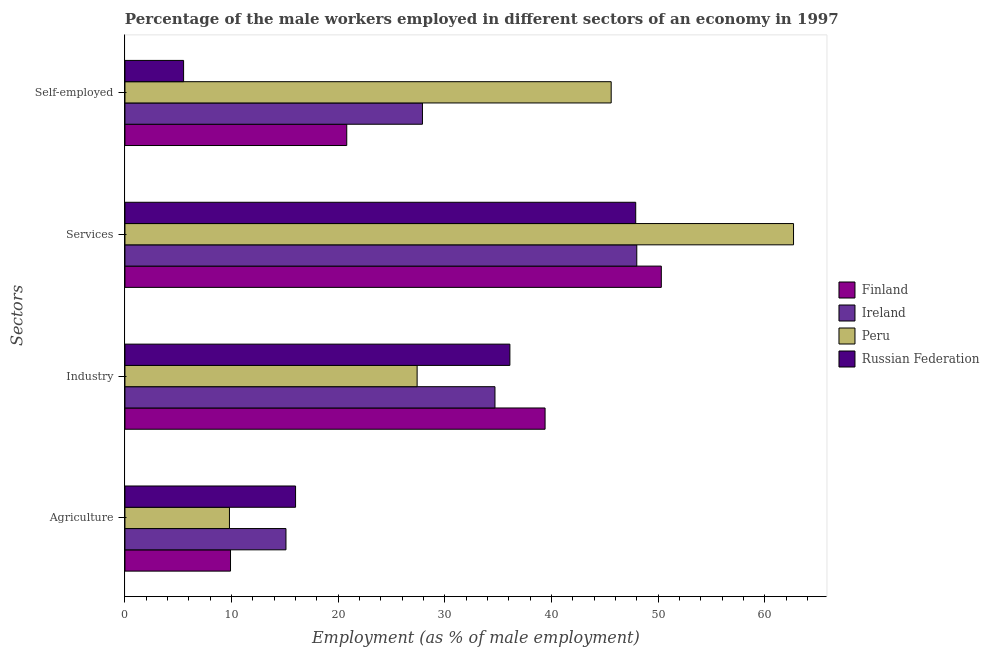How many different coloured bars are there?
Offer a terse response. 4. How many bars are there on the 4th tick from the top?
Make the answer very short. 4. What is the label of the 4th group of bars from the top?
Provide a succinct answer. Agriculture. What is the percentage of male workers in agriculture in Finland?
Offer a terse response. 9.9. Across all countries, what is the maximum percentage of male workers in industry?
Your response must be concise. 39.4. In which country was the percentage of male workers in agriculture maximum?
Offer a very short reply. Russian Federation. In which country was the percentage of male workers in agriculture minimum?
Provide a short and direct response. Peru. What is the total percentage of male workers in agriculture in the graph?
Give a very brief answer. 50.8. What is the difference between the percentage of self employed male workers in Russian Federation and that in Peru?
Keep it short and to the point. -40.1. What is the difference between the percentage of self employed male workers in Russian Federation and the percentage of male workers in services in Peru?
Give a very brief answer. -57.2. What is the average percentage of male workers in industry per country?
Your answer should be very brief. 34.4. What is the difference between the percentage of male workers in agriculture and percentage of male workers in services in Peru?
Make the answer very short. -52.9. What is the ratio of the percentage of male workers in industry in Russian Federation to that in Peru?
Your answer should be very brief. 1.32. Is the percentage of male workers in industry in Russian Federation less than that in Finland?
Your answer should be very brief. Yes. Is the difference between the percentage of male workers in industry in Ireland and Russian Federation greater than the difference between the percentage of male workers in services in Ireland and Russian Federation?
Provide a short and direct response. No. What is the difference between the highest and the second highest percentage of self employed male workers?
Your answer should be compact. 17.7. What is the difference between the highest and the lowest percentage of male workers in agriculture?
Give a very brief answer. 6.2. Is the sum of the percentage of male workers in services in Finland and Peru greater than the maximum percentage of self employed male workers across all countries?
Offer a terse response. Yes. What does the 3rd bar from the top in Services represents?
Give a very brief answer. Ireland. How many bars are there?
Provide a succinct answer. 16. Are all the bars in the graph horizontal?
Provide a short and direct response. Yes. Does the graph contain any zero values?
Make the answer very short. No. What is the title of the graph?
Ensure brevity in your answer.  Percentage of the male workers employed in different sectors of an economy in 1997. What is the label or title of the X-axis?
Give a very brief answer. Employment (as % of male employment). What is the label or title of the Y-axis?
Give a very brief answer. Sectors. What is the Employment (as % of male employment) in Finland in Agriculture?
Ensure brevity in your answer.  9.9. What is the Employment (as % of male employment) of Ireland in Agriculture?
Offer a terse response. 15.1. What is the Employment (as % of male employment) of Peru in Agriculture?
Offer a terse response. 9.8. What is the Employment (as % of male employment) of Russian Federation in Agriculture?
Give a very brief answer. 16. What is the Employment (as % of male employment) of Finland in Industry?
Ensure brevity in your answer.  39.4. What is the Employment (as % of male employment) of Ireland in Industry?
Keep it short and to the point. 34.7. What is the Employment (as % of male employment) of Peru in Industry?
Offer a very short reply. 27.4. What is the Employment (as % of male employment) of Russian Federation in Industry?
Ensure brevity in your answer.  36.1. What is the Employment (as % of male employment) of Finland in Services?
Make the answer very short. 50.3. What is the Employment (as % of male employment) in Ireland in Services?
Offer a terse response. 48. What is the Employment (as % of male employment) of Peru in Services?
Your answer should be very brief. 62.7. What is the Employment (as % of male employment) of Russian Federation in Services?
Offer a very short reply. 47.9. What is the Employment (as % of male employment) of Finland in Self-employed?
Ensure brevity in your answer.  20.8. What is the Employment (as % of male employment) in Ireland in Self-employed?
Your answer should be compact. 27.9. What is the Employment (as % of male employment) in Peru in Self-employed?
Your response must be concise. 45.6. What is the Employment (as % of male employment) in Russian Federation in Self-employed?
Offer a very short reply. 5.5. Across all Sectors, what is the maximum Employment (as % of male employment) in Finland?
Provide a short and direct response. 50.3. Across all Sectors, what is the maximum Employment (as % of male employment) of Ireland?
Offer a very short reply. 48. Across all Sectors, what is the maximum Employment (as % of male employment) of Peru?
Offer a very short reply. 62.7. Across all Sectors, what is the maximum Employment (as % of male employment) of Russian Federation?
Give a very brief answer. 47.9. Across all Sectors, what is the minimum Employment (as % of male employment) in Finland?
Offer a very short reply. 9.9. Across all Sectors, what is the minimum Employment (as % of male employment) of Ireland?
Offer a very short reply. 15.1. Across all Sectors, what is the minimum Employment (as % of male employment) in Peru?
Keep it short and to the point. 9.8. Across all Sectors, what is the minimum Employment (as % of male employment) in Russian Federation?
Your answer should be compact. 5.5. What is the total Employment (as % of male employment) of Finland in the graph?
Offer a terse response. 120.4. What is the total Employment (as % of male employment) in Ireland in the graph?
Offer a very short reply. 125.7. What is the total Employment (as % of male employment) of Peru in the graph?
Offer a very short reply. 145.5. What is the total Employment (as % of male employment) of Russian Federation in the graph?
Ensure brevity in your answer.  105.5. What is the difference between the Employment (as % of male employment) of Finland in Agriculture and that in Industry?
Keep it short and to the point. -29.5. What is the difference between the Employment (as % of male employment) in Ireland in Agriculture and that in Industry?
Give a very brief answer. -19.6. What is the difference between the Employment (as % of male employment) of Peru in Agriculture and that in Industry?
Ensure brevity in your answer.  -17.6. What is the difference between the Employment (as % of male employment) in Russian Federation in Agriculture and that in Industry?
Make the answer very short. -20.1. What is the difference between the Employment (as % of male employment) of Finland in Agriculture and that in Services?
Provide a short and direct response. -40.4. What is the difference between the Employment (as % of male employment) in Ireland in Agriculture and that in Services?
Keep it short and to the point. -32.9. What is the difference between the Employment (as % of male employment) in Peru in Agriculture and that in Services?
Keep it short and to the point. -52.9. What is the difference between the Employment (as % of male employment) in Russian Federation in Agriculture and that in Services?
Give a very brief answer. -31.9. What is the difference between the Employment (as % of male employment) in Ireland in Agriculture and that in Self-employed?
Offer a terse response. -12.8. What is the difference between the Employment (as % of male employment) of Peru in Agriculture and that in Self-employed?
Provide a succinct answer. -35.8. What is the difference between the Employment (as % of male employment) of Russian Federation in Agriculture and that in Self-employed?
Keep it short and to the point. 10.5. What is the difference between the Employment (as % of male employment) in Finland in Industry and that in Services?
Offer a terse response. -10.9. What is the difference between the Employment (as % of male employment) in Ireland in Industry and that in Services?
Offer a very short reply. -13.3. What is the difference between the Employment (as % of male employment) of Peru in Industry and that in Services?
Your answer should be compact. -35.3. What is the difference between the Employment (as % of male employment) in Ireland in Industry and that in Self-employed?
Make the answer very short. 6.8. What is the difference between the Employment (as % of male employment) of Peru in Industry and that in Self-employed?
Provide a succinct answer. -18.2. What is the difference between the Employment (as % of male employment) of Russian Federation in Industry and that in Self-employed?
Your response must be concise. 30.6. What is the difference between the Employment (as % of male employment) of Finland in Services and that in Self-employed?
Provide a short and direct response. 29.5. What is the difference between the Employment (as % of male employment) in Ireland in Services and that in Self-employed?
Keep it short and to the point. 20.1. What is the difference between the Employment (as % of male employment) of Russian Federation in Services and that in Self-employed?
Your answer should be very brief. 42.4. What is the difference between the Employment (as % of male employment) in Finland in Agriculture and the Employment (as % of male employment) in Ireland in Industry?
Offer a terse response. -24.8. What is the difference between the Employment (as % of male employment) of Finland in Agriculture and the Employment (as % of male employment) of Peru in Industry?
Give a very brief answer. -17.5. What is the difference between the Employment (as % of male employment) of Finland in Agriculture and the Employment (as % of male employment) of Russian Federation in Industry?
Offer a terse response. -26.2. What is the difference between the Employment (as % of male employment) of Peru in Agriculture and the Employment (as % of male employment) of Russian Federation in Industry?
Keep it short and to the point. -26.3. What is the difference between the Employment (as % of male employment) in Finland in Agriculture and the Employment (as % of male employment) in Ireland in Services?
Ensure brevity in your answer.  -38.1. What is the difference between the Employment (as % of male employment) of Finland in Agriculture and the Employment (as % of male employment) of Peru in Services?
Provide a short and direct response. -52.8. What is the difference between the Employment (as % of male employment) in Finland in Agriculture and the Employment (as % of male employment) in Russian Federation in Services?
Offer a terse response. -38. What is the difference between the Employment (as % of male employment) in Ireland in Agriculture and the Employment (as % of male employment) in Peru in Services?
Ensure brevity in your answer.  -47.6. What is the difference between the Employment (as % of male employment) of Ireland in Agriculture and the Employment (as % of male employment) of Russian Federation in Services?
Provide a succinct answer. -32.8. What is the difference between the Employment (as % of male employment) of Peru in Agriculture and the Employment (as % of male employment) of Russian Federation in Services?
Give a very brief answer. -38.1. What is the difference between the Employment (as % of male employment) in Finland in Agriculture and the Employment (as % of male employment) in Ireland in Self-employed?
Your answer should be compact. -18. What is the difference between the Employment (as % of male employment) of Finland in Agriculture and the Employment (as % of male employment) of Peru in Self-employed?
Make the answer very short. -35.7. What is the difference between the Employment (as % of male employment) in Finland in Agriculture and the Employment (as % of male employment) in Russian Federation in Self-employed?
Keep it short and to the point. 4.4. What is the difference between the Employment (as % of male employment) of Ireland in Agriculture and the Employment (as % of male employment) of Peru in Self-employed?
Keep it short and to the point. -30.5. What is the difference between the Employment (as % of male employment) of Finland in Industry and the Employment (as % of male employment) of Ireland in Services?
Your response must be concise. -8.6. What is the difference between the Employment (as % of male employment) of Finland in Industry and the Employment (as % of male employment) of Peru in Services?
Your answer should be very brief. -23.3. What is the difference between the Employment (as % of male employment) in Finland in Industry and the Employment (as % of male employment) in Russian Federation in Services?
Your answer should be compact. -8.5. What is the difference between the Employment (as % of male employment) of Ireland in Industry and the Employment (as % of male employment) of Peru in Services?
Offer a very short reply. -28. What is the difference between the Employment (as % of male employment) in Ireland in Industry and the Employment (as % of male employment) in Russian Federation in Services?
Offer a terse response. -13.2. What is the difference between the Employment (as % of male employment) in Peru in Industry and the Employment (as % of male employment) in Russian Federation in Services?
Give a very brief answer. -20.5. What is the difference between the Employment (as % of male employment) in Finland in Industry and the Employment (as % of male employment) in Russian Federation in Self-employed?
Provide a short and direct response. 33.9. What is the difference between the Employment (as % of male employment) in Ireland in Industry and the Employment (as % of male employment) in Peru in Self-employed?
Give a very brief answer. -10.9. What is the difference between the Employment (as % of male employment) in Ireland in Industry and the Employment (as % of male employment) in Russian Federation in Self-employed?
Provide a short and direct response. 29.2. What is the difference between the Employment (as % of male employment) of Peru in Industry and the Employment (as % of male employment) of Russian Federation in Self-employed?
Your response must be concise. 21.9. What is the difference between the Employment (as % of male employment) of Finland in Services and the Employment (as % of male employment) of Ireland in Self-employed?
Your response must be concise. 22.4. What is the difference between the Employment (as % of male employment) in Finland in Services and the Employment (as % of male employment) in Peru in Self-employed?
Make the answer very short. 4.7. What is the difference between the Employment (as % of male employment) of Finland in Services and the Employment (as % of male employment) of Russian Federation in Self-employed?
Your answer should be very brief. 44.8. What is the difference between the Employment (as % of male employment) of Ireland in Services and the Employment (as % of male employment) of Russian Federation in Self-employed?
Offer a very short reply. 42.5. What is the difference between the Employment (as % of male employment) of Peru in Services and the Employment (as % of male employment) of Russian Federation in Self-employed?
Make the answer very short. 57.2. What is the average Employment (as % of male employment) in Finland per Sectors?
Offer a terse response. 30.1. What is the average Employment (as % of male employment) of Ireland per Sectors?
Make the answer very short. 31.43. What is the average Employment (as % of male employment) of Peru per Sectors?
Your answer should be compact. 36.38. What is the average Employment (as % of male employment) of Russian Federation per Sectors?
Provide a short and direct response. 26.38. What is the difference between the Employment (as % of male employment) in Finland and Employment (as % of male employment) in Ireland in Agriculture?
Make the answer very short. -5.2. What is the difference between the Employment (as % of male employment) of Finland and Employment (as % of male employment) of Peru in Agriculture?
Your answer should be compact. 0.1. What is the difference between the Employment (as % of male employment) in Ireland and Employment (as % of male employment) in Peru in Agriculture?
Make the answer very short. 5.3. What is the difference between the Employment (as % of male employment) in Ireland and Employment (as % of male employment) in Russian Federation in Agriculture?
Your answer should be compact. -0.9. What is the difference between the Employment (as % of male employment) of Finland and Employment (as % of male employment) of Ireland in Industry?
Give a very brief answer. 4.7. What is the difference between the Employment (as % of male employment) in Finland and Employment (as % of male employment) in Russian Federation in Industry?
Your answer should be compact. 3.3. What is the difference between the Employment (as % of male employment) of Ireland and Employment (as % of male employment) of Russian Federation in Industry?
Keep it short and to the point. -1.4. What is the difference between the Employment (as % of male employment) of Peru and Employment (as % of male employment) of Russian Federation in Industry?
Your answer should be compact. -8.7. What is the difference between the Employment (as % of male employment) of Finland and Employment (as % of male employment) of Ireland in Services?
Your answer should be very brief. 2.3. What is the difference between the Employment (as % of male employment) in Finland and Employment (as % of male employment) in Peru in Services?
Ensure brevity in your answer.  -12.4. What is the difference between the Employment (as % of male employment) in Ireland and Employment (as % of male employment) in Peru in Services?
Offer a terse response. -14.7. What is the difference between the Employment (as % of male employment) in Ireland and Employment (as % of male employment) in Russian Federation in Services?
Your answer should be very brief. 0.1. What is the difference between the Employment (as % of male employment) in Peru and Employment (as % of male employment) in Russian Federation in Services?
Keep it short and to the point. 14.8. What is the difference between the Employment (as % of male employment) in Finland and Employment (as % of male employment) in Ireland in Self-employed?
Ensure brevity in your answer.  -7.1. What is the difference between the Employment (as % of male employment) of Finland and Employment (as % of male employment) of Peru in Self-employed?
Make the answer very short. -24.8. What is the difference between the Employment (as % of male employment) in Ireland and Employment (as % of male employment) in Peru in Self-employed?
Give a very brief answer. -17.7. What is the difference between the Employment (as % of male employment) of Ireland and Employment (as % of male employment) of Russian Federation in Self-employed?
Keep it short and to the point. 22.4. What is the difference between the Employment (as % of male employment) in Peru and Employment (as % of male employment) in Russian Federation in Self-employed?
Your answer should be very brief. 40.1. What is the ratio of the Employment (as % of male employment) of Finland in Agriculture to that in Industry?
Your answer should be very brief. 0.25. What is the ratio of the Employment (as % of male employment) in Ireland in Agriculture to that in Industry?
Ensure brevity in your answer.  0.44. What is the ratio of the Employment (as % of male employment) of Peru in Agriculture to that in Industry?
Your response must be concise. 0.36. What is the ratio of the Employment (as % of male employment) in Russian Federation in Agriculture to that in Industry?
Offer a very short reply. 0.44. What is the ratio of the Employment (as % of male employment) in Finland in Agriculture to that in Services?
Provide a succinct answer. 0.2. What is the ratio of the Employment (as % of male employment) of Ireland in Agriculture to that in Services?
Make the answer very short. 0.31. What is the ratio of the Employment (as % of male employment) in Peru in Agriculture to that in Services?
Provide a succinct answer. 0.16. What is the ratio of the Employment (as % of male employment) in Russian Federation in Agriculture to that in Services?
Offer a terse response. 0.33. What is the ratio of the Employment (as % of male employment) in Finland in Agriculture to that in Self-employed?
Provide a succinct answer. 0.48. What is the ratio of the Employment (as % of male employment) of Ireland in Agriculture to that in Self-employed?
Provide a succinct answer. 0.54. What is the ratio of the Employment (as % of male employment) in Peru in Agriculture to that in Self-employed?
Your answer should be very brief. 0.21. What is the ratio of the Employment (as % of male employment) in Russian Federation in Agriculture to that in Self-employed?
Provide a succinct answer. 2.91. What is the ratio of the Employment (as % of male employment) in Finland in Industry to that in Services?
Give a very brief answer. 0.78. What is the ratio of the Employment (as % of male employment) in Ireland in Industry to that in Services?
Give a very brief answer. 0.72. What is the ratio of the Employment (as % of male employment) in Peru in Industry to that in Services?
Your answer should be very brief. 0.44. What is the ratio of the Employment (as % of male employment) in Russian Federation in Industry to that in Services?
Provide a short and direct response. 0.75. What is the ratio of the Employment (as % of male employment) of Finland in Industry to that in Self-employed?
Make the answer very short. 1.89. What is the ratio of the Employment (as % of male employment) of Ireland in Industry to that in Self-employed?
Offer a terse response. 1.24. What is the ratio of the Employment (as % of male employment) in Peru in Industry to that in Self-employed?
Give a very brief answer. 0.6. What is the ratio of the Employment (as % of male employment) in Russian Federation in Industry to that in Self-employed?
Keep it short and to the point. 6.56. What is the ratio of the Employment (as % of male employment) in Finland in Services to that in Self-employed?
Your response must be concise. 2.42. What is the ratio of the Employment (as % of male employment) of Ireland in Services to that in Self-employed?
Ensure brevity in your answer.  1.72. What is the ratio of the Employment (as % of male employment) in Peru in Services to that in Self-employed?
Provide a succinct answer. 1.38. What is the ratio of the Employment (as % of male employment) of Russian Federation in Services to that in Self-employed?
Your answer should be compact. 8.71. What is the difference between the highest and the second highest Employment (as % of male employment) of Ireland?
Give a very brief answer. 13.3. What is the difference between the highest and the second highest Employment (as % of male employment) of Russian Federation?
Your answer should be very brief. 11.8. What is the difference between the highest and the lowest Employment (as % of male employment) in Finland?
Your answer should be very brief. 40.4. What is the difference between the highest and the lowest Employment (as % of male employment) of Ireland?
Your answer should be compact. 32.9. What is the difference between the highest and the lowest Employment (as % of male employment) in Peru?
Your response must be concise. 52.9. What is the difference between the highest and the lowest Employment (as % of male employment) in Russian Federation?
Give a very brief answer. 42.4. 